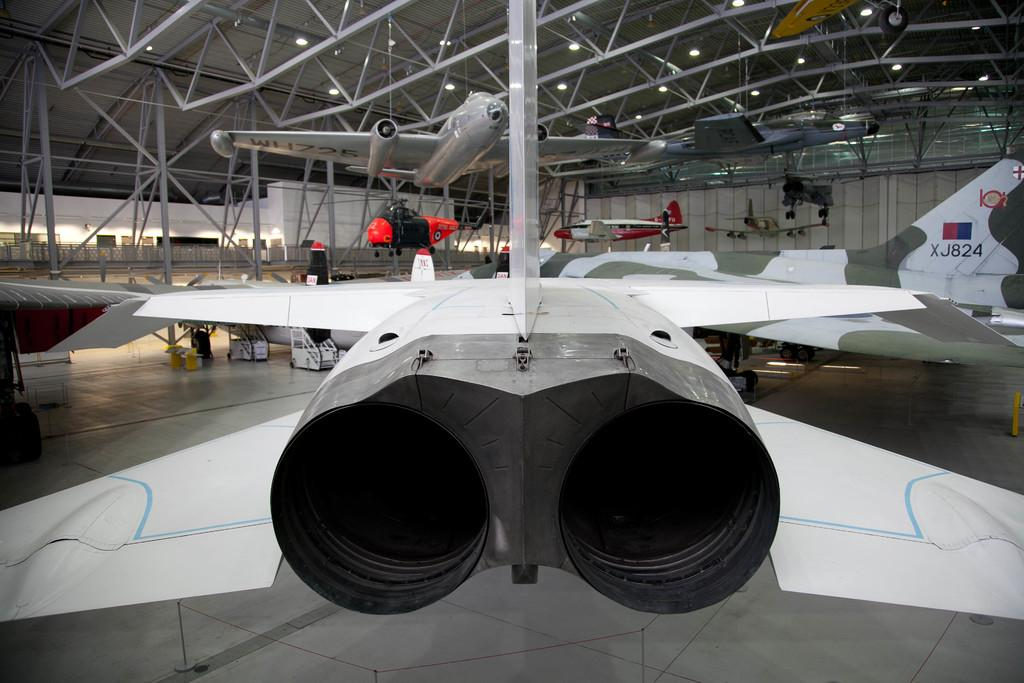<image>
Offer a succinct explanation of the picture presented. Jet planes in a hangar and one has XJ824 on it's tail. 